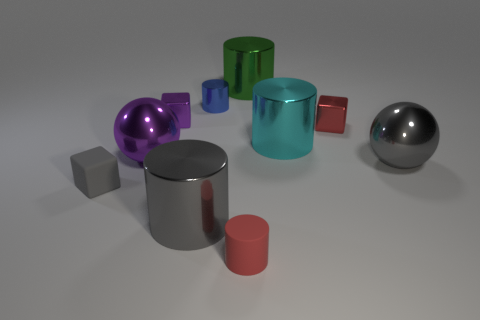What number of large things are brown matte objects or blue cylinders?
Provide a succinct answer. 0. Is the size of the cyan cylinder the same as the red object left of the green shiny cylinder?
Offer a terse response. No. What number of matte things are there?
Give a very brief answer. 2. What number of red things are big balls or matte cylinders?
Your answer should be very brief. 1. Are the large sphere in front of the large purple sphere and the tiny gray thing made of the same material?
Your response must be concise. No. What number of other objects are there of the same material as the small blue cylinder?
Offer a very short reply. 7. What is the small red cylinder made of?
Provide a short and direct response. Rubber. There is a ball that is left of the tiny red rubber cylinder; how big is it?
Make the answer very short. Large. There is a ball that is right of the gray cylinder; how many metal objects are to the left of it?
Your answer should be compact. 7. There is a tiny rubber object on the right side of the small purple object; does it have the same shape as the thing behind the small blue metal object?
Ensure brevity in your answer.  Yes. 